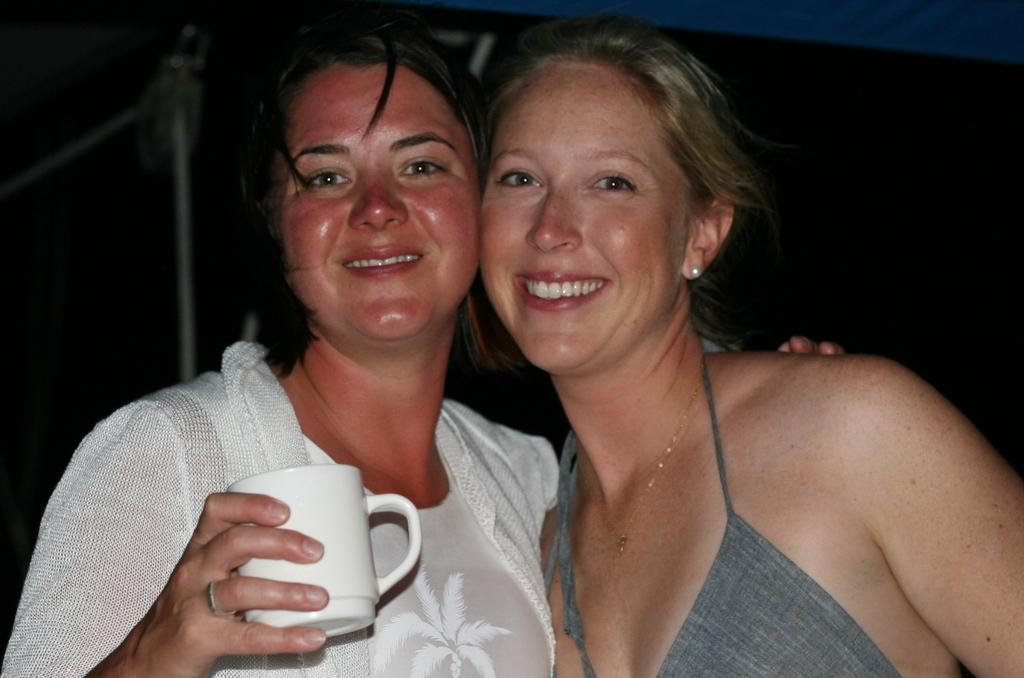How many people are in the image? There are two persons in the image. What is one of the persons holding in her hand? One of the persons is holding a cup with her hand. What is the facial expression of the persons in the image? Both persons are smiling. What month is it in the image? The month cannot be determined from the image, as there is no information about the time of year or any seasonal indicators present. 